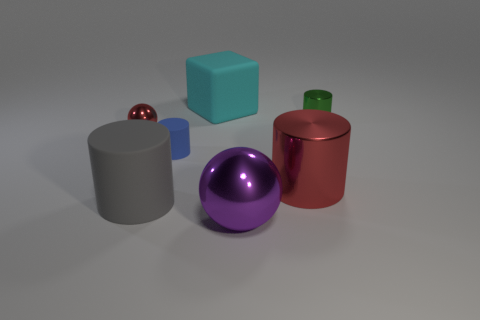Subtract all green cylinders. How many cylinders are left? 3 Subtract all big red metallic cylinders. How many cylinders are left? 3 Subtract all brown cylinders. Subtract all blue spheres. How many cylinders are left? 4 Add 2 small green spheres. How many objects exist? 9 Subtract all balls. How many objects are left? 5 Add 2 brown things. How many brown things exist? 2 Subtract 0 cyan balls. How many objects are left? 7 Subtract all yellow metal blocks. Subtract all cyan matte blocks. How many objects are left? 6 Add 7 spheres. How many spheres are left? 9 